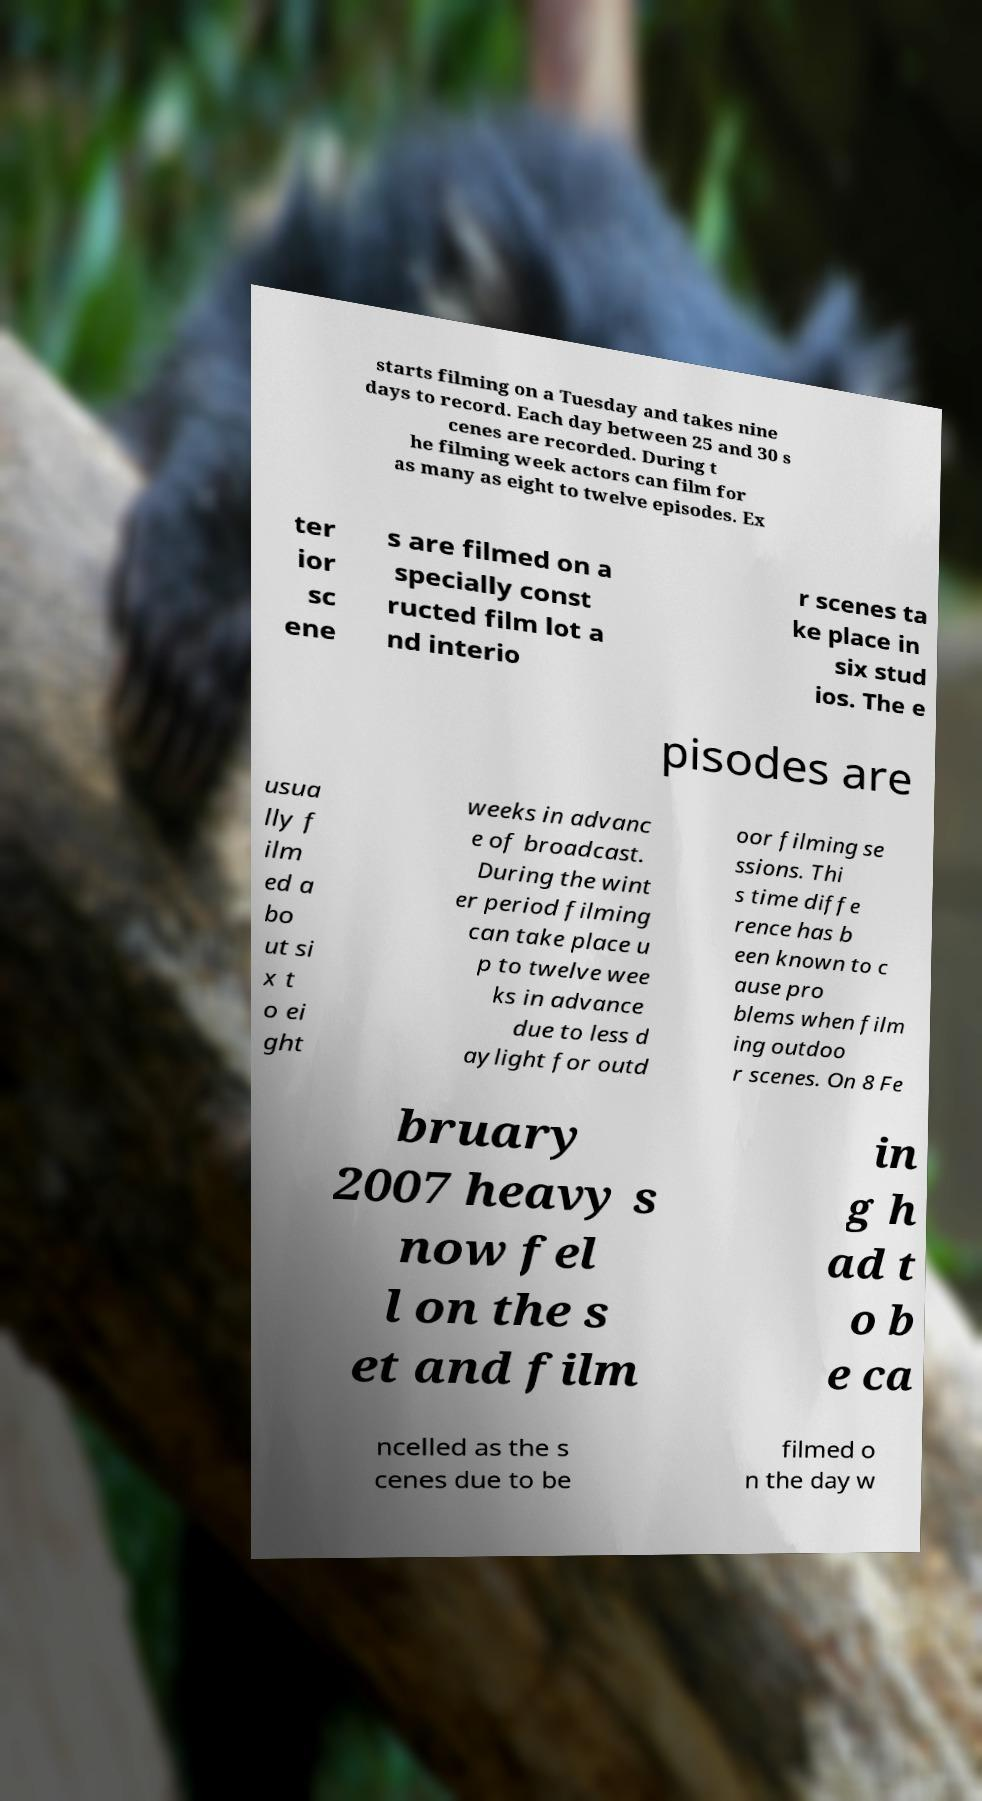Please read and relay the text visible in this image. What does it say? starts filming on a Tuesday and takes nine days to record. Each day between 25 and 30 s cenes are recorded. During t he filming week actors can film for as many as eight to twelve episodes. Ex ter ior sc ene s are filmed on a specially const ructed film lot a nd interio r scenes ta ke place in six stud ios. The e pisodes are usua lly f ilm ed a bo ut si x t o ei ght weeks in advanc e of broadcast. During the wint er period filming can take place u p to twelve wee ks in advance due to less d aylight for outd oor filming se ssions. Thi s time diffe rence has b een known to c ause pro blems when film ing outdoo r scenes. On 8 Fe bruary 2007 heavy s now fel l on the s et and film in g h ad t o b e ca ncelled as the s cenes due to be filmed o n the day w 